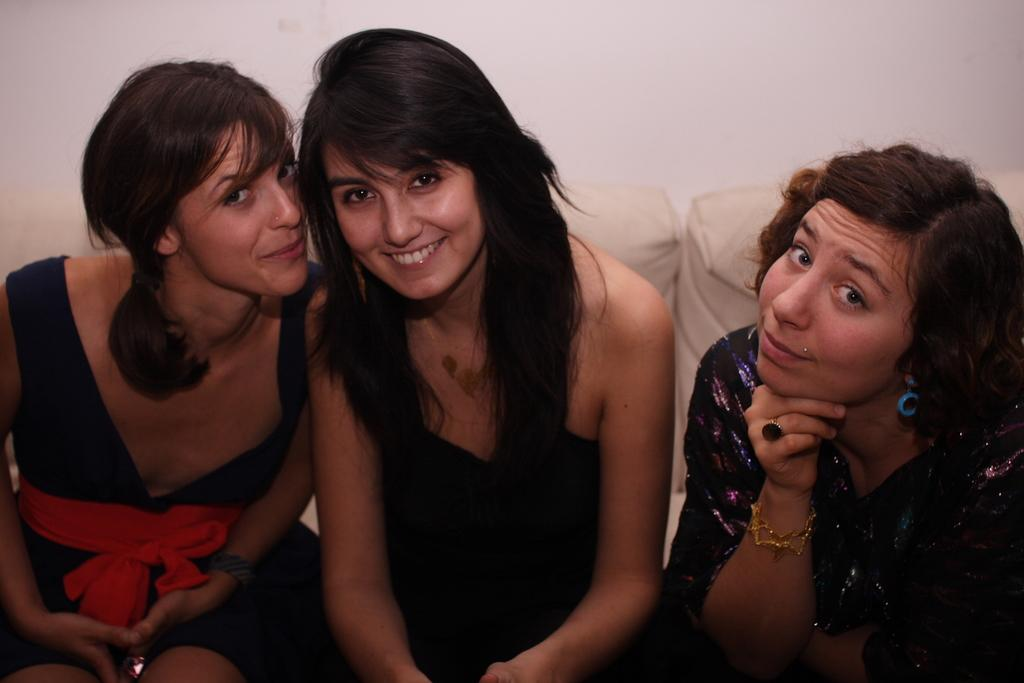How many people are in the image? There are three ladies in the image. What are the ladies doing in the image? The ladies are sitting on a sofa. What can be seen in the background of the image? There is a wall in the background of the image. What type of lift is present in the image? There is no lift present in the image; it features three ladies sitting on a sofa. What drug are the ladies taking in the image? There is no indication in the image that the ladies are taking any drugs. 